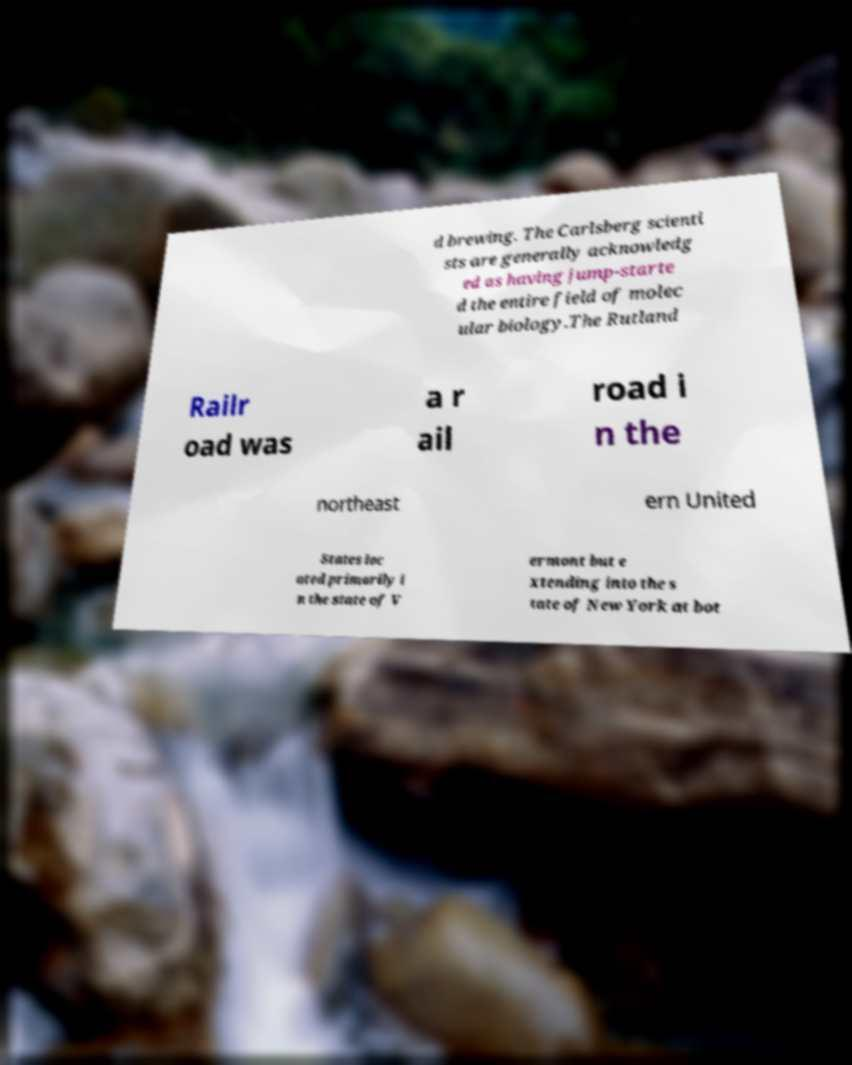Can you read and provide the text displayed in the image?This photo seems to have some interesting text. Can you extract and type it out for me? d brewing. The Carlsberg scienti sts are generally acknowledg ed as having jump-starte d the entire field of molec ular biology.The Rutland Railr oad was a r ail road i n the northeast ern United States loc ated primarily i n the state of V ermont but e xtending into the s tate of New York at bot 